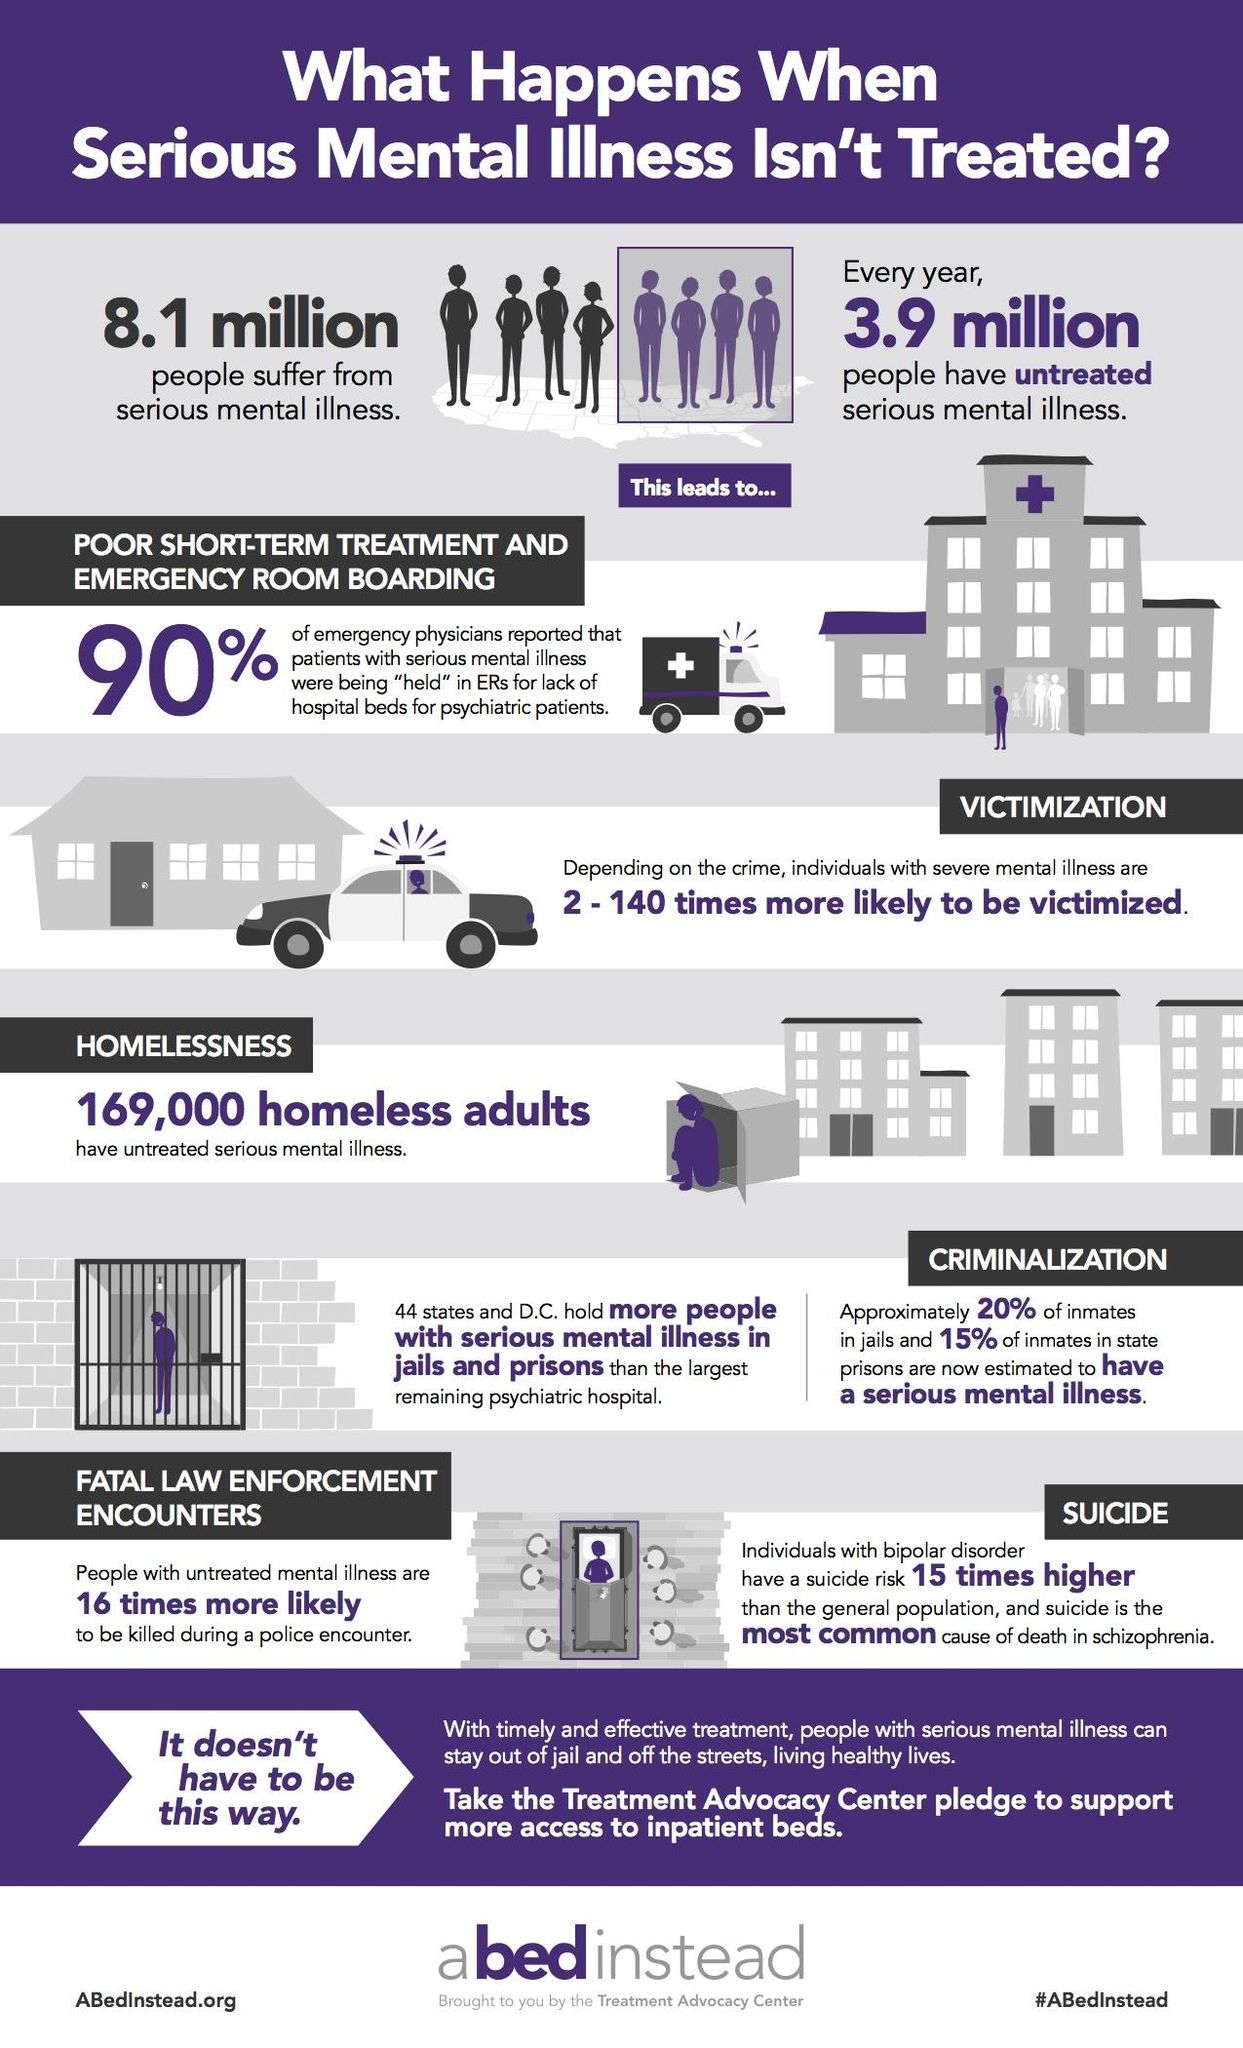Outline some significant characteristics in this image. According to a recent estimate, approximately 8.1 million people in the United States suffer from serious mental illness. Suicide is the most common cause of death in individuals with schizophrenia. There is a 16-fold increase in fatal encounters between law enforcement and individuals with mental illness. According to the National Institute of Mental Health, approximately 3.9 million individuals in the United States have serious mental illnesses that have gone untreated. In comparison to psychiatric hospitals, jails and prisons are known to hold a larger number of individuals with serious mental illnesses. 